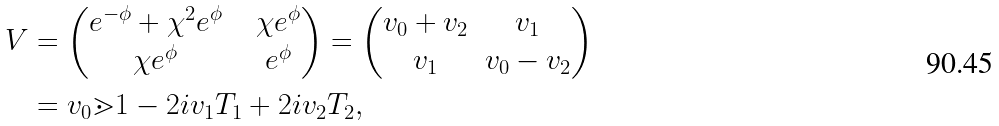<formula> <loc_0><loc_0><loc_500><loc_500>V & = \begin{pmatrix} e ^ { - \phi } + \chi ^ { 2 } e ^ { \phi } & & \chi e ^ { \phi } \\ \chi e ^ { \phi } & & e ^ { \phi } \end{pmatrix} = \begin{pmatrix} v _ { 0 } + v _ { 2 } & v _ { 1 } \\ v _ { 1 } & v _ { 0 } - v _ { 2 } \end{pmatrix} \\ & = v _ { 0 } \mathbb { m } { 1 } - 2 i v _ { 1 } T _ { 1 } + 2 i v _ { 2 } T _ { 2 } ,</formula> 